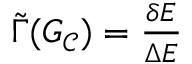Convert formula to latex. <formula><loc_0><loc_0><loc_500><loc_500>\begin{array} { r } { \tilde { \Gamma } ( G _ { \mathcal { C } } ) = \frac { \delta E } { \Delta E } } \end{array}</formula> 